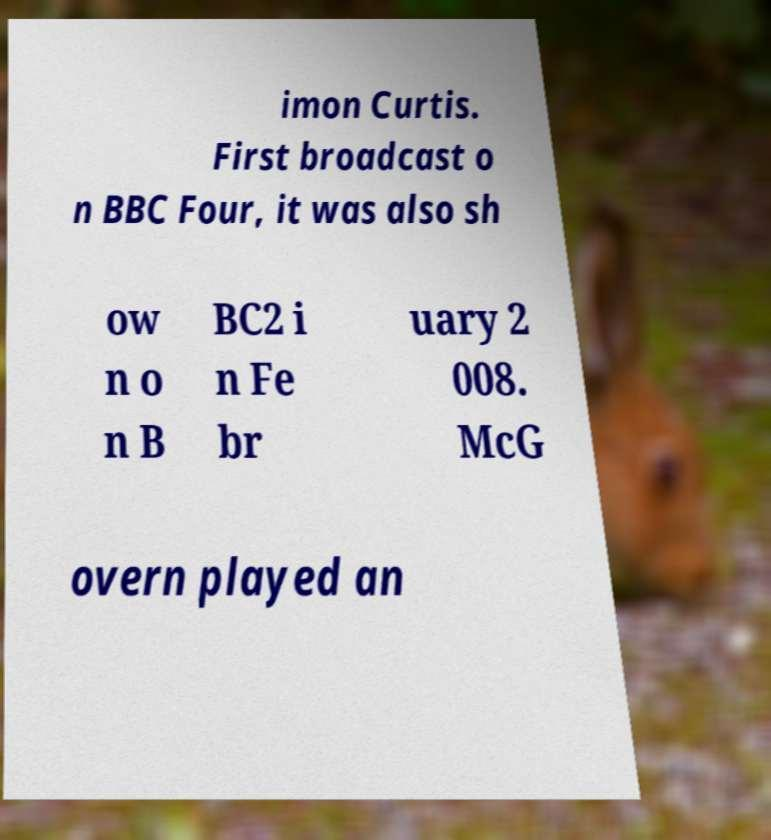Can you read and provide the text displayed in the image?This photo seems to have some interesting text. Can you extract and type it out for me? imon Curtis. First broadcast o n BBC Four, it was also sh ow n o n B BC2 i n Fe br uary 2 008. McG overn played an 